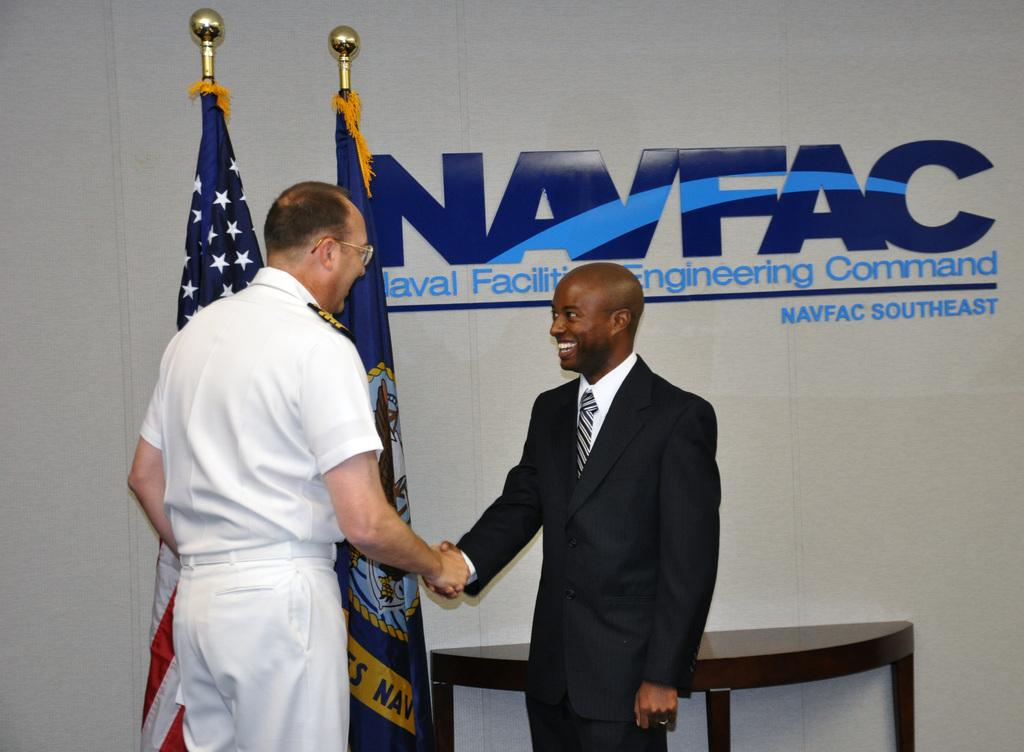<image>
Summarize the visual content of the image. two men shaking hands with a NAVFAC ad behind them 